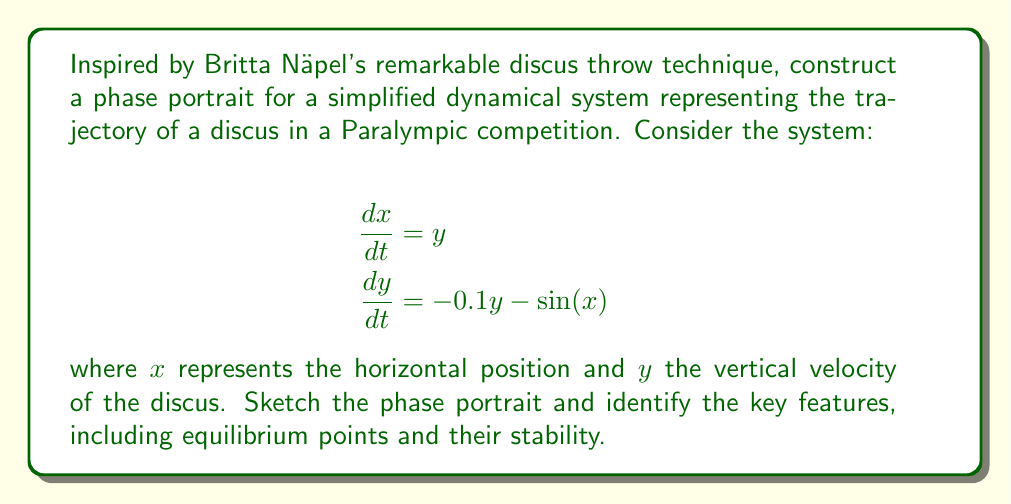Give your solution to this math problem. To construct the phase portrait for this dynamical system, we'll follow these steps:

1) Identify equilibrium points:
   Set $\frac{dx}{dt} = 0$ and $\frac{dy}{dt} = 0$
   
   $y = 0$
   $-0.1y - \sin(x) = 0$
   $\sin(x) = 0$
   
   This occurs when $x = n\pi$, where $n$ is an integer.
   Equilibrium points are $(0,0)$, $(\pi,0)$, $(-\pi,0)$, $(2\pi,0)$, $(-2\pi,0)$, etc.

2) Analyze stability of equilibrium points:
   Jacobian matrix: $J = \begin{bmatrix} 0 & 1 \\ -\cos(x) & -0.1 \end{bmatrix}$
   
   At $(0,0)$: $J = \begin{bmatrix} 0 & 1 \\ -1 & -0.1 \end{bmatrix}$
   Eigenvalues: $\lambda \approx -0.05 \pm 0.999i$
   This is a stable spiral point.
   
   At $(\pi,0)$: $J = \begin{bmatrix} 0 & 1 \\ 1 & -0.1 \end{bmatrix}$
   Eigenvalues: $\lambda_1 > 0$, $\lambda_2 < 0$
   This is a saddle point.

3) Sketch nullclines:
   $\dot{x} = 0$ when $y = 0$ (x-axis)
   $\dot{y} = 0$ when $y = -10\sin(x)$ (sinusoidal curve)

4) Determine vector field:
   Arrows point right when $y > 0$, left when $y < 0$
   Arrows point up when $-0.1y > \sin(x)$, down when $-0.1y < \sin(x)$

5) Sketch trajectories:
   - Spiral into $(0,0)$, $(2\pi,0)$, $(-2\pi,0)$, etc.
   - Move away from $(\pi,0)$, $(-\pi,0)$, $(3\pi,0)$, etc.
   - Follow the vector field, crossing nullclines perpendicularly

[asy]
import graph;
size(200);
xaxis("x",-7,7,Arrow);
yaxis("y",-3,3,Arrow);

real f(real x) {return -10*sin(x);}
draw(graph(f,-7,7),blue);

for(int i=-2; i<=2; ++i) {
  dot((i*pi,0));
}

draw((0,0)--(0.5,0.5),Arrow);
draw((pi,0)--(pi+0.5,-0.5),Arrow);
draw((pi,0)--(pi-0.5,0.5),Arrow);
draw((-1,2)..(-0.5,1)..(0,0)..(0.5,-1)..(1,-2),red);
draw((2,2)..(2.5,1)..(3,0)..(3.5,-1)..(4,-2),red);
</asy]
Answer: Phase portrait: stable spiral points at $(2n\pi,0)$, saddle points at $((2n+1)\pi,0)$, trajectories spiral into stable points and diverge from saddle points. 